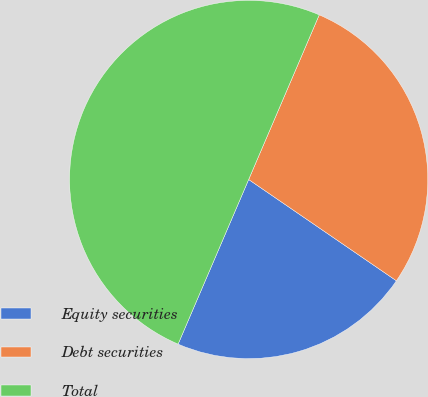Convert chart. <chart><loc_0><loc_0><loc_500><loc_500><pie_chart><fcel>Equity securities<fcel>Debt securities<fcel>Total<nl><fcel>21.88%<fcel>28.12%<fcel>50.0%<nl></chart> 